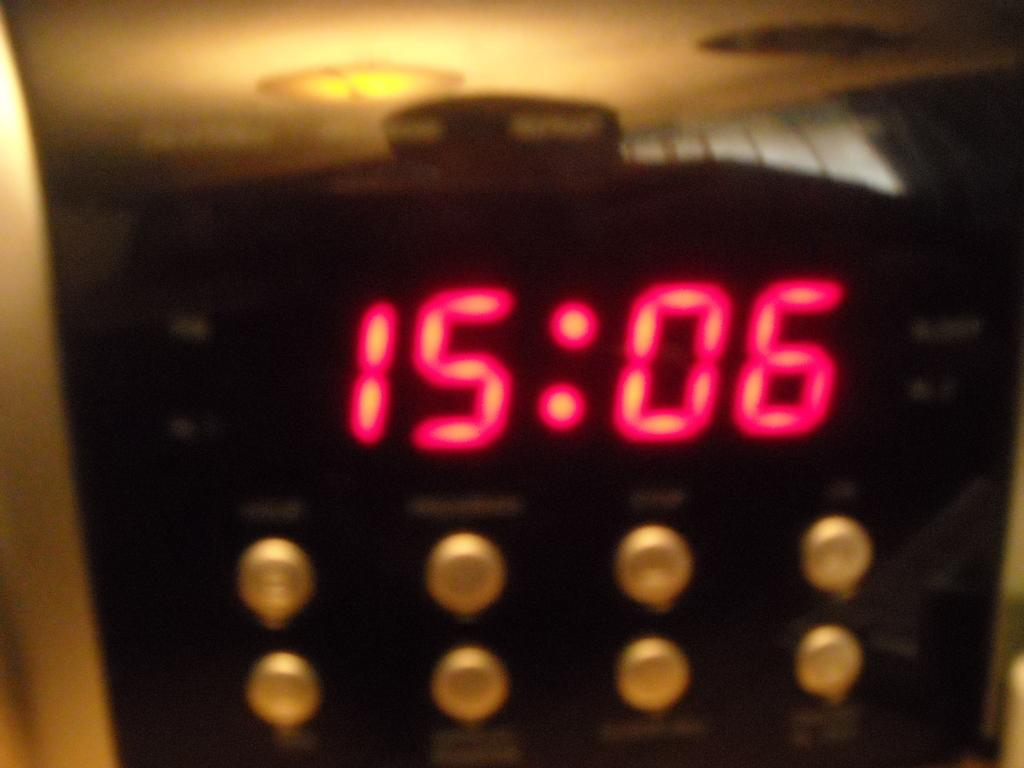<image>
Present a compact description of the photo's key features. A digital clock displaying the military time of 15:06 